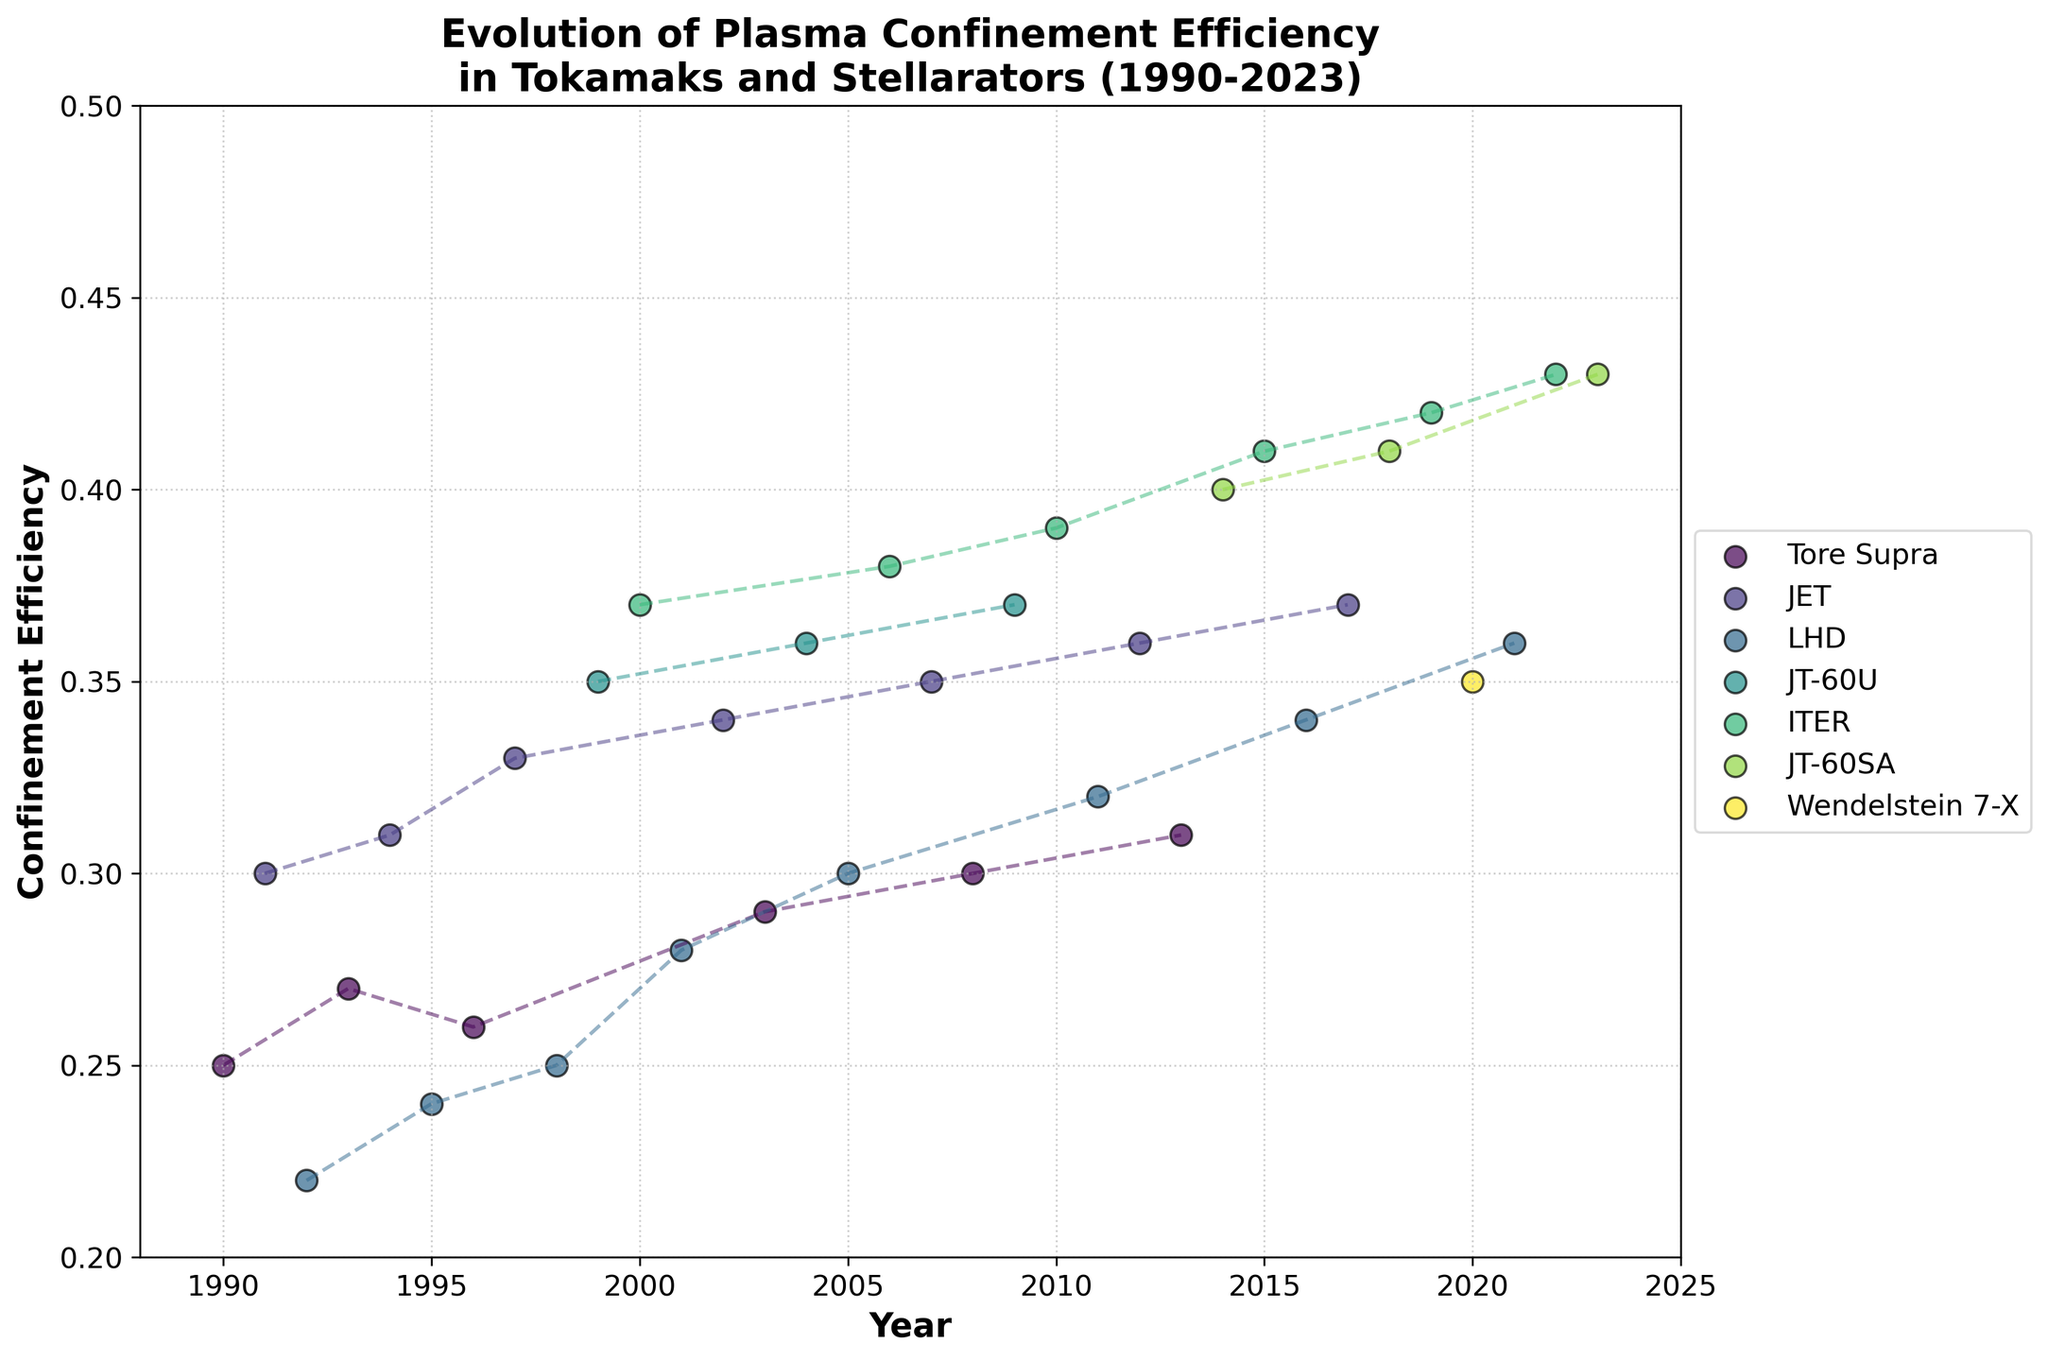Which year had the highest plasma confinement efficiency, and which device achieved it? Reviewing the vertical range of the plot, the highest confinement efficiency value seems to be 0.43, as indicated towards the far right of the x-axis. This value corresponds to the years 2022 and 2023. For 2022, ITER achieved 0.43, and for 2023, JT-60SA achieved the same value.
Answer: 2022 by ITER and 2023 by JT-60SA In which year did ITER first appear on the plot, and what was the confinement efficiency value that year? The first appearance of ITER in the plot can be found by looking for the initial data point marked for ITER. The data place it in the year 2000, with a confinement efficiency of 0.37.
Answer: 2000, 0.37 Which device shows a consistent increase in confinement efficiency over the years? Observing the time series for each device, ITER shows a consistent increase in confinement efficiency, starting from 0.37 in 2000 to 0.43 in 2022.
Answer: ITER Compare the confinement efficiency of JET in 2007 and 2017. Which year had the higher efficiency, and what is the difference? By checking the plot for JET around the years 2007 and 2017, it is evident that 2017 has a higher confinement efficiency (0.37) compared to 2007 (0.35). The difference between 2017 and 2007 is 0.02.
Answer: 2017, 0.02 Which device had the lowest confinement efficiency in 1990? The only device noted in the year 1990 on the plot is Tore Supra, with a confinement efficiency of 0.25. This is the lowest value noted for 1990.
Answer: Tore Supra How many different devices are shown in the plot spanning the years 1990-2023? By inspecting the unique markers for each device along the x-axis, the plot indicates seven different devices: Tore Supra, JET, LHD, JT-60U, ITER, JT-60SA, and Wendelstein 7-X.
Answer: 7 What is the average confinement efficiency for LHD across all its appearances? Summarizing the vertical positions attributed to LHD over its years (0.22, 0.24, 0.25, 0.28, 0.30, 0.32, 0.34, 0.36) and dividing by the number of instances (8),  the calculation yields an average confinement efficiency of (0.22 + 0.24 + 0.25 + 0.28 + 0.30 + 0.32 + 0.34 + 0.36)/8 = 0.289.
Answer: 0.289 